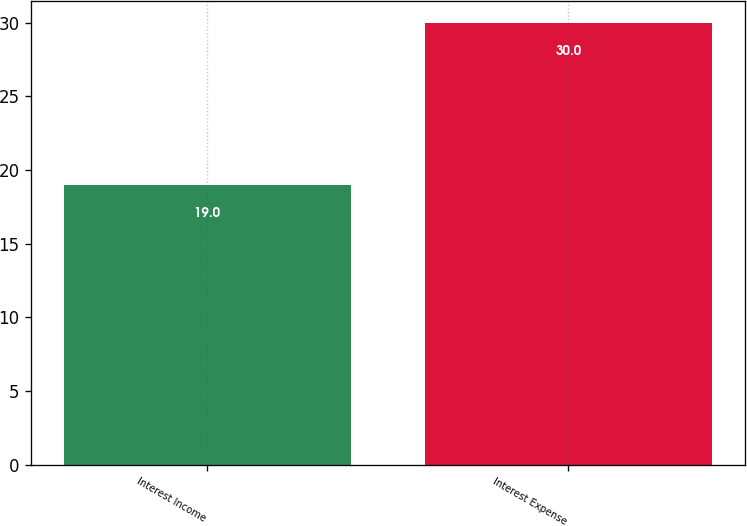Convert chart. <chart><loc_0><loc_0><loc_500><loc_500><bar_chart><fcel>Interest Income<fcel>Interest Expense<nl><fcel>19<fcel>30<nl></chart> 